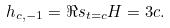<formula> <loc_0><loc_0><loc_500><loc_500>h _ { c , - 1 } = \Re s _ { t = c } H = 3 c .</formula> 